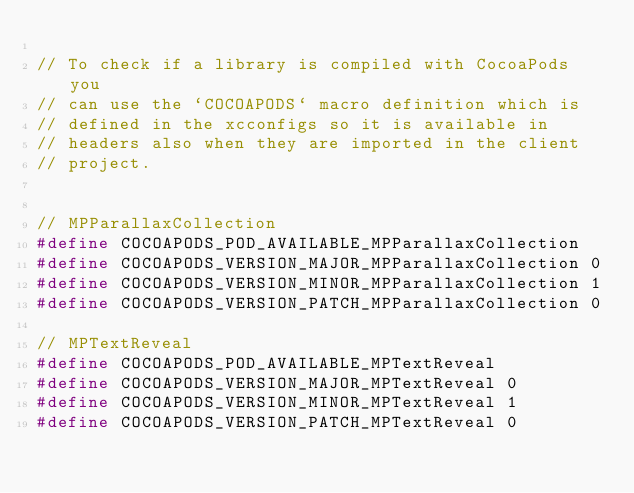<code> <loc_0><loc_0><loc_500><loc_500><_C_>
// To check if a library is compiled with CocoaPods you
// can use the `COCOAPODS` macro definition which is
// defined in the xcconfigs so it is available in
// headers also when they are imported in the client
// project.


// MPParallaxCollection
#define COCOAPODS_POD_AVAILABLE_MPParallaxCollection
#define COCOAPODS_VERSION_MAJOR_MPParallaxCollection 0
#define COCOAPODS_VERSION_MINOR_MPParallaxCollection 1
#define COCOAPODS_VERSION_PATCH_MPParallaxCollection 0

// MPTextReveal
#define COCOAPODS_POD_AVAILABLE_MPTextReveal
#define COCOAPODS_VERSION_MAJOR_MPTextReveal 0
#define COCOAPODS_VERSION_MINOR_MPTextReveal 1
#define COCOAPODS_VERSION_PATCH_MPTextReveal 0

</code> 